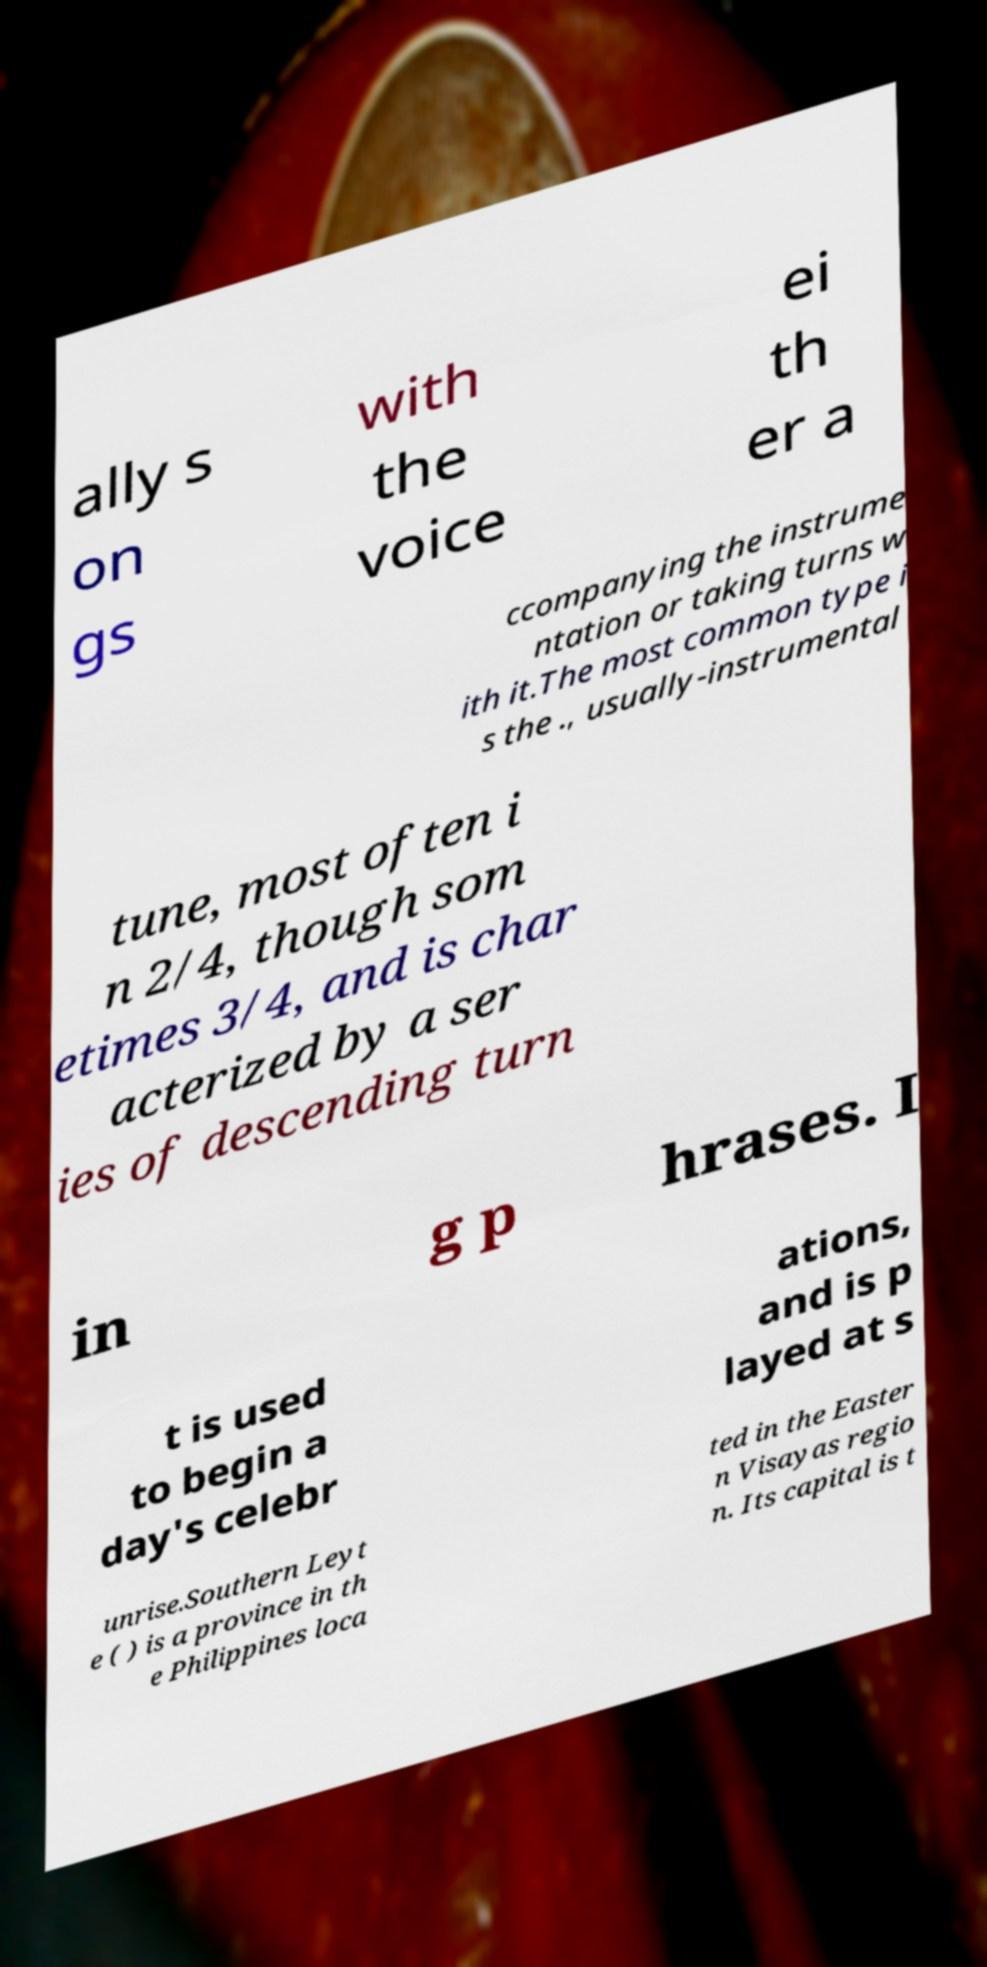Please read and relay the text visible in this image. What does it say? ally s on gs with the voice ei th er a ccompanying the instrume ntation or taking turns w ith it.The most common type i s the ., usually-instrumental tune, most often i n 2/4, though som etimes 3/4, and is char acterized by a ser ies of descending turn in g p hrases. I t is used to begin a day's celebr ations, and is p layed at s unrise.Southern Leyt e ( ) is a province in th e Philippines loca ted in the Easter n Visayas regio n. Its capital is t 